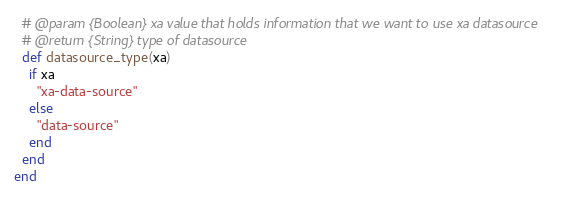Convert code to text. <code><loc_0><loc_0><loc_500><loc_500><_Ruby_>  # @param {Boolean} xa value that holds information that we want to use xa datasource
  # @return {String} type of datasource
  def datasource_type(xa)
    if xa
      "xa-data-source"
    else
      "data-source"
    end
  end
end
</code> 